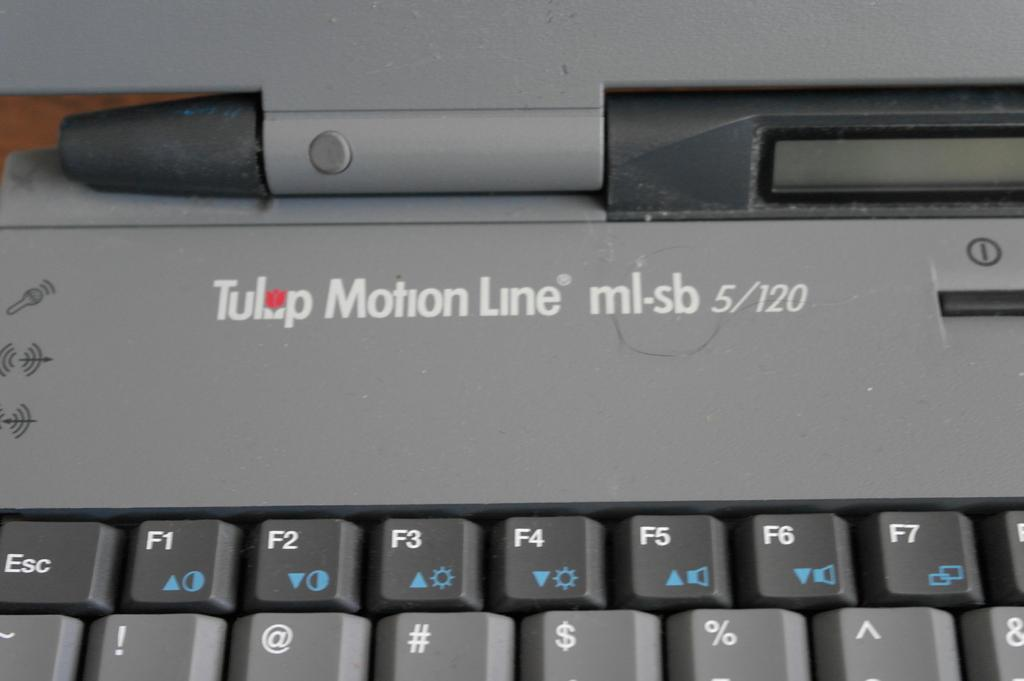<image>
Describe the image concisely. A keyboard has the name Tulip Motion Line written above the F-number keys. 